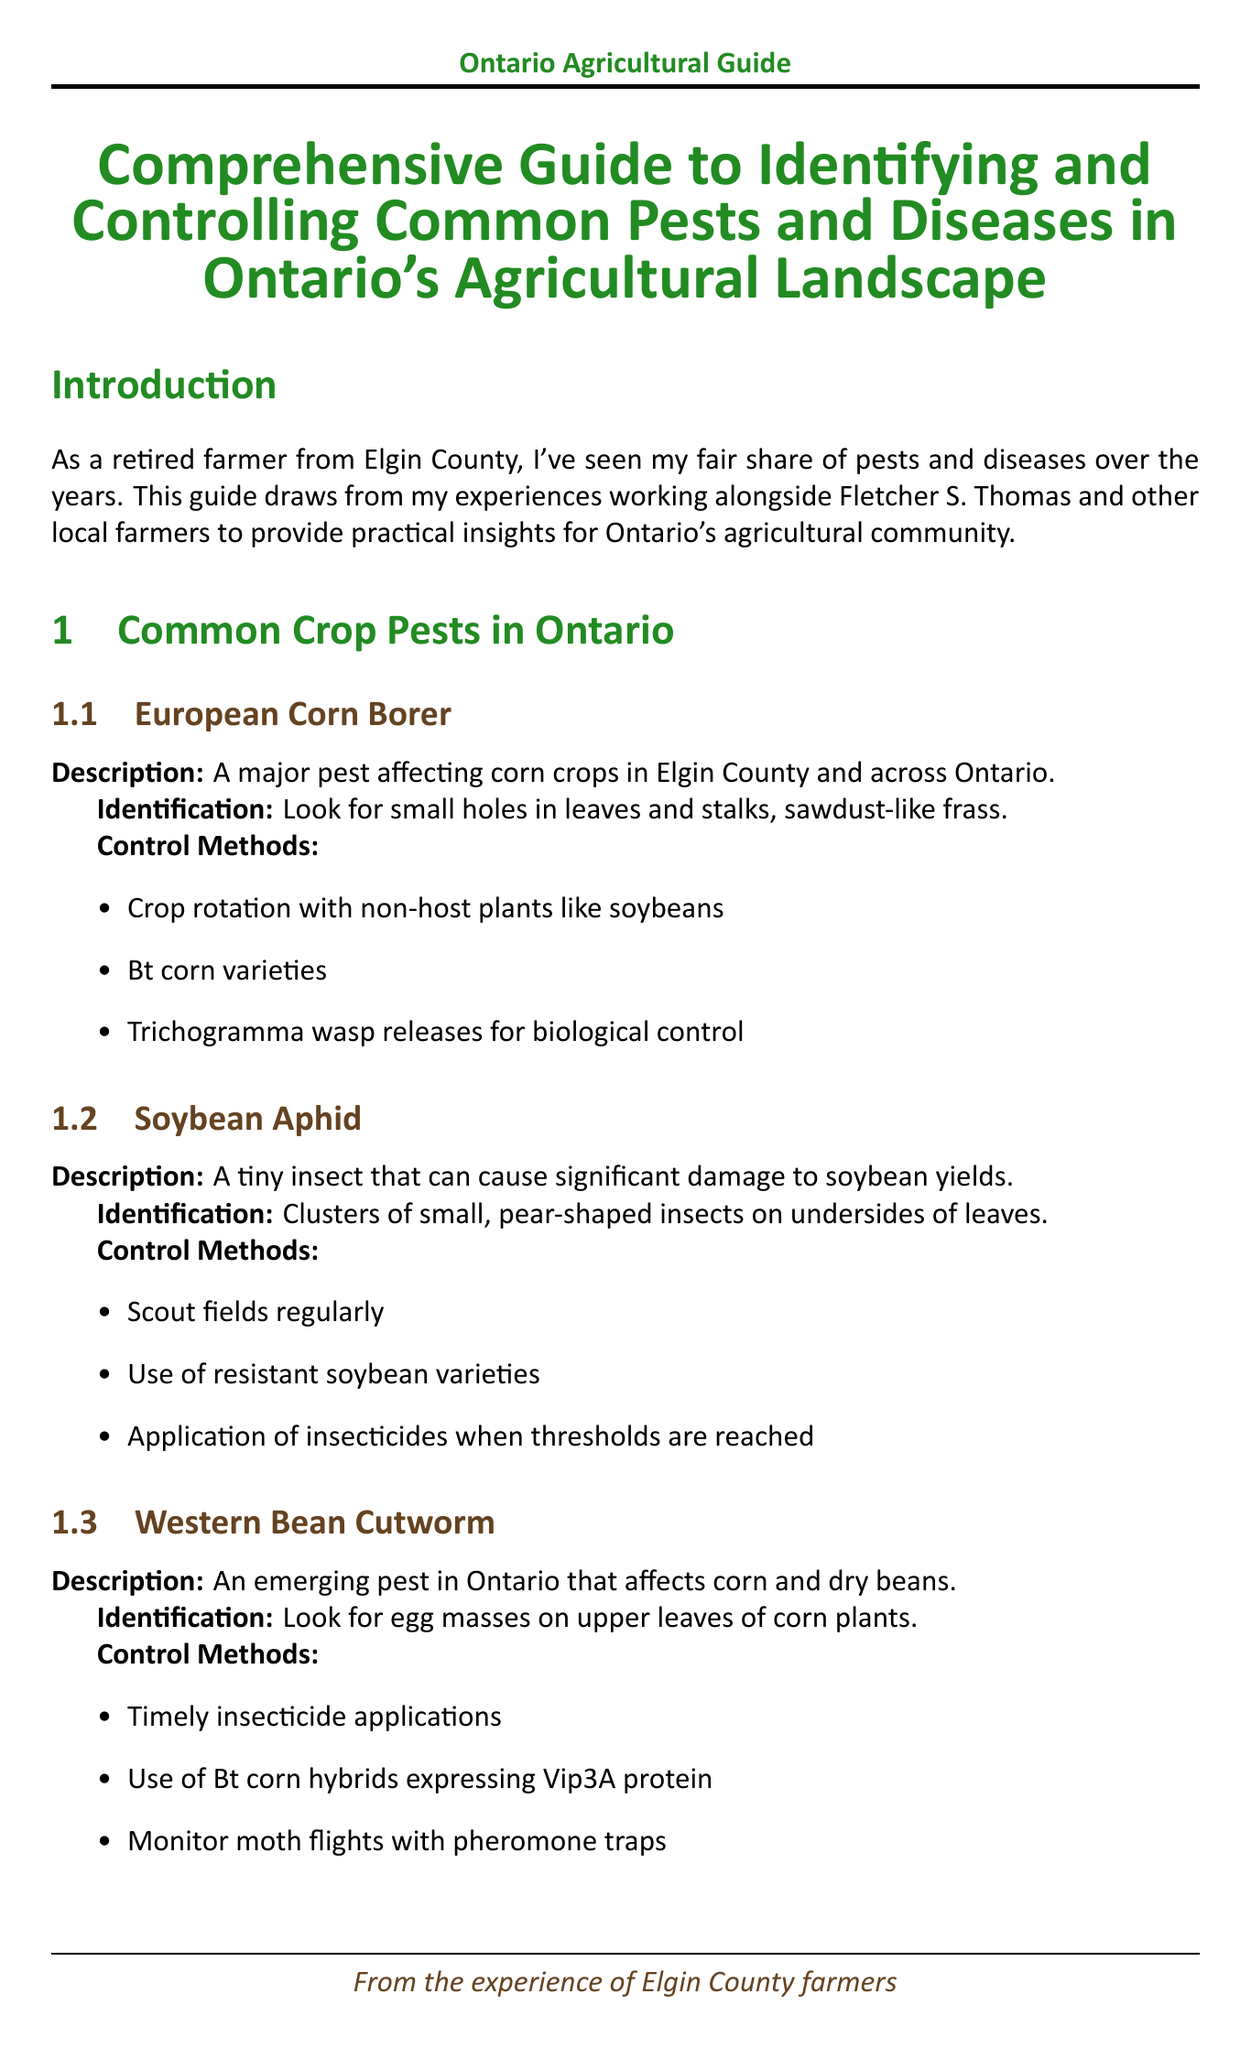What is the main focus of the guide? The guide provides insights on pest and disease management tailored for Ontario's agricultural landscape.
Answer: Pest and disease management What pest affects corn crops in Elgin County? The document specifies a major pest affecting corn crops.
Answer: European Corn Borer Which insect is known for damaging soybean yields? The document highlights a tiny insect that significantly impacts soybean crops.
Answer: Soybean Aphid What disease affects wheat and small grains? The guide mentions a specific disease that devastates wheat crops.
Answer: Fusarium Head Blight What are two control methods for Sudden Death Syndrome in soybeans? The document outlines specific control methods for this soil-borne disease.
Answer: Plant resistant varieties, Improve field drainage What is a benefit of crop rotation according to the document? The guide discusses a fundamental practice that disrupts pest life cycles.
Answer: Disrupts pest life cycles Name one resource provided by the Ontario Ministry of Agriculture. The document lists services offered by this ministry.
Answer: Crop pest hotline What tool is used for weather monitoring in Ontario? The guide mentions tools used for predicting pest and disease outbreaks.
Answer: Ontario Weather Network How can biological control be defined in this context? The document defines a strategy for controlling pest populations using natural means.
Answer: Utilizing natural predators and parasites What should farmers do when pest thresholds are reached? The document recommends a specific action in response to pest population levels.
Answer: Application of insecticides 